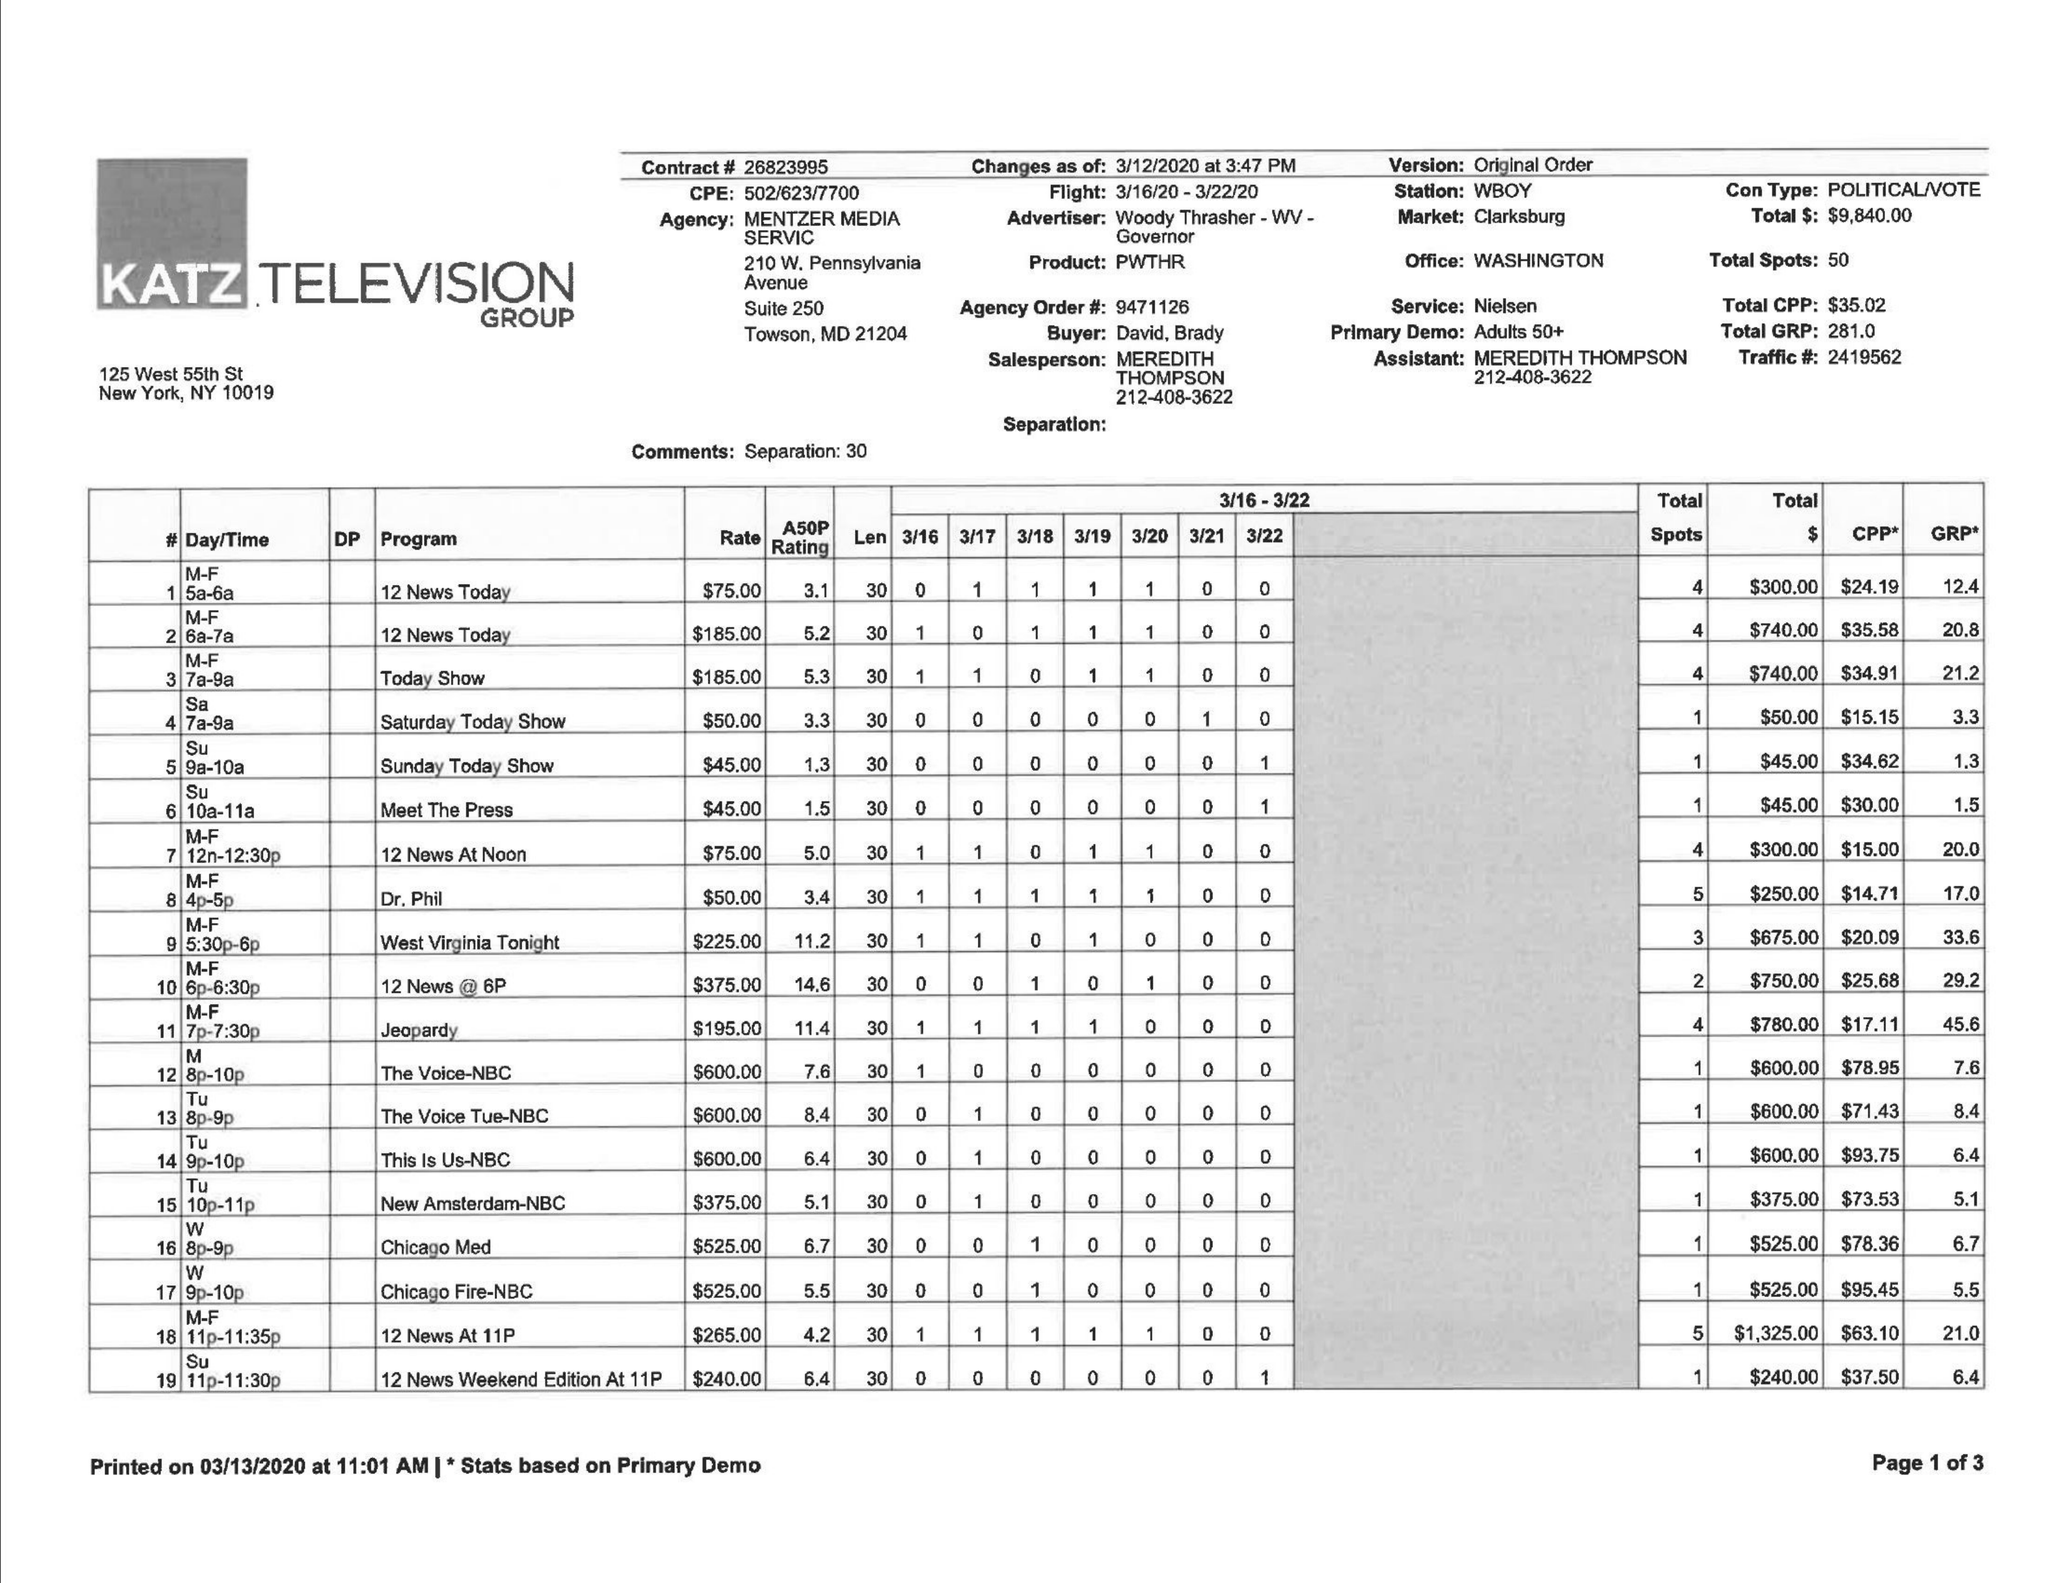What is the value for the flight_to?
Answer the question using a single word or phrase. 03/22/20 